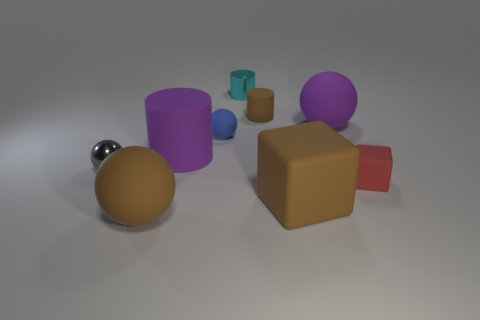Can you describe the lighting and shadows in the scene? The lighting in the scene appears to be diffuse, coming from above as indicated by the soft shadows cast directly underneath the objects. This type of lighting suggests an ambient source, likely intended to minimize harsh shadows and provide even illumination of the objects. 